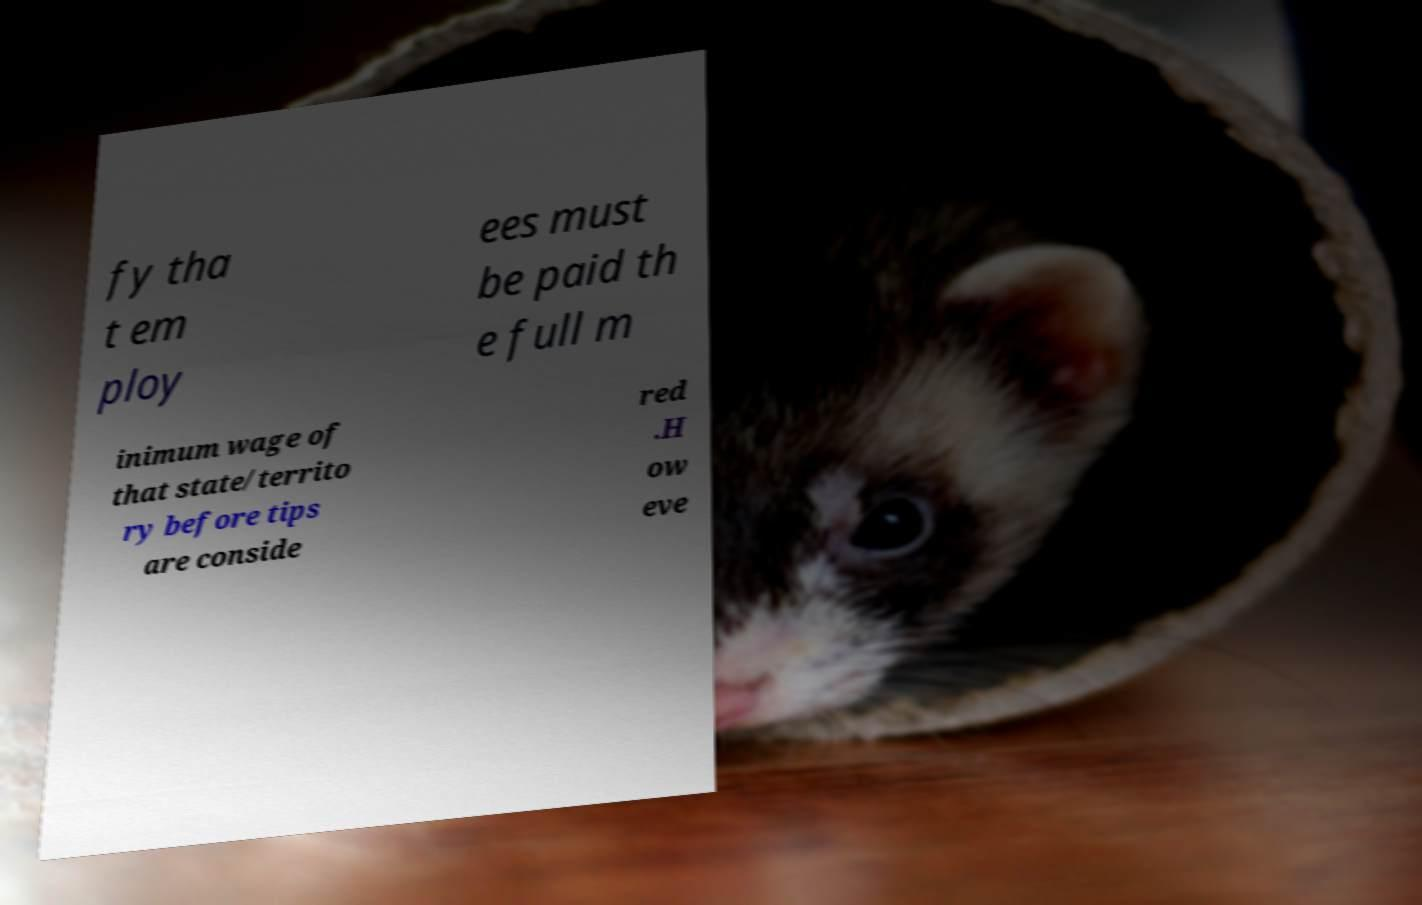Can you accurately transcribe the text from the provided image for me? fy tha t em ploy ees must be paid th e full m inimum wage of that state/territo ry before tips are conside red .H ow eve 